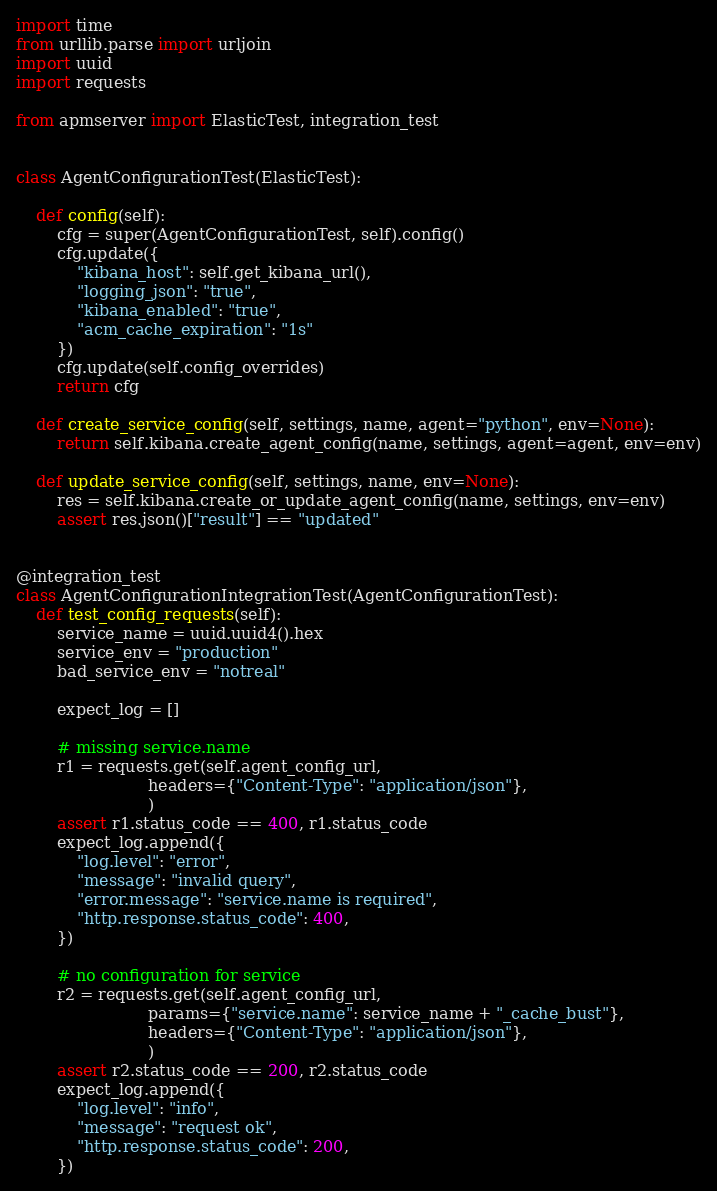<code> <loc_0><loc_0><loc_500><loc_500><_Python_>import time
from urllib.parse import urljoin
import uuid
import requests

from apmserver import ElasticTest, integration_test


class AgentConfigurationTest(ElasticTest):

    def config(self):
        cfg = super(AgentConfigurationTest, self).config()
        cfg.update({
            "kibana_host": self.get_kibana_url(),
            "logging_json": "true",
            "kibana_enabled": "true",
            "acm_cache_expiration": "1s"
        })
        cfg.update(self.config_overrides)
        return cfg

    def create_service_config(self, settings, name, agent="python", env=None):
        return self.kibana.create_agent_config(name, settings, agent=agent, env=env)

    def update_service_config(self, settings, name, env=None):
        res = self.kibana.create_or_update_agent_config(name, settings, env=env)
        assert res.json()["result"] == "updated"


@integration_test
class AgentConfigurationIntegrationTest(AgentConfigurationTest):
    def test_config_requests(self):
        service_name = uuid.uuid4().hex
        service_env = "production"
        bad_service_env = "notreal"

        expect_log = []

        # missing service.name
        r1 = requests.get(self.agent_config_url,
                          headers={"Content-Type": "application/json"},
                          )
        assert r1.status_code == 400, r1.status_code
        expect_log.append({
            "log.level": "error",
            "message": "invalid query",
            "error.message": "service.name is required",
            "http.response.status_code": 400,
        })

        # no configuration for service
        r2 = requests.get(self.agent_config_url,
                          params={"service.name": service_name + "_cache_bust"},
                          headers={"Content-Type": "application/json"},
                          )
        assert r2.status_code == 200, r2.status_code
        expect_log.append({
            "log.level": "info",
            "message": "request ok",
            "http.response.status_code": 200,
        })</code> 